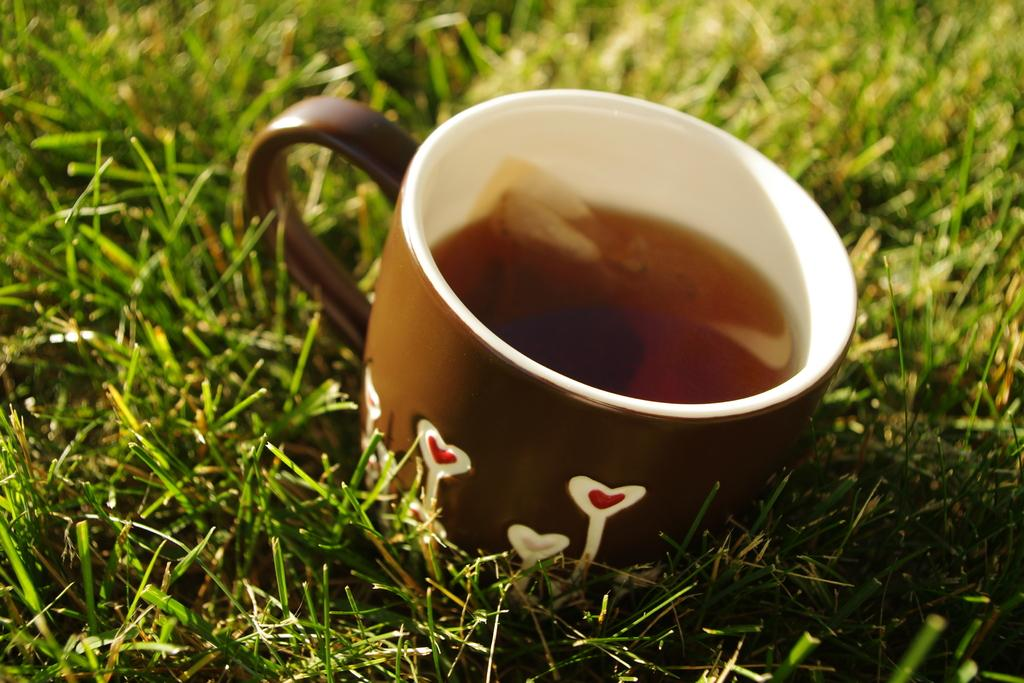What color is the cup in the image? The cup in the image is brown. What is inside the cup? The cup contains a liquid. Where is the cup located? The cup is on the grass. What is the grass situated on? The grass is on the ground. How would you describe the background of the image? The background of the image is blurred. What type of hat is the calendar wearing in the image? There is no hat or calendar present in the image. 